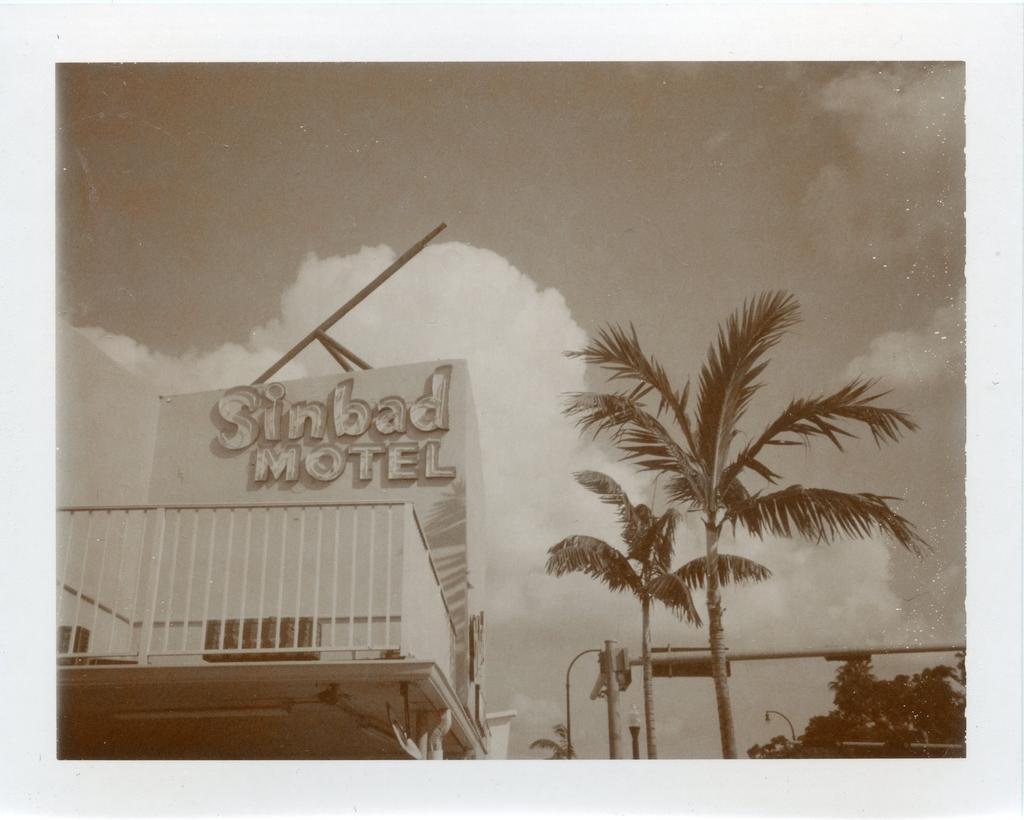Could you give a brief overview of what you see in this image? This is a black and white image and here we can see a building, trees, poles and lights and at the top, there are clouds in the sky. 